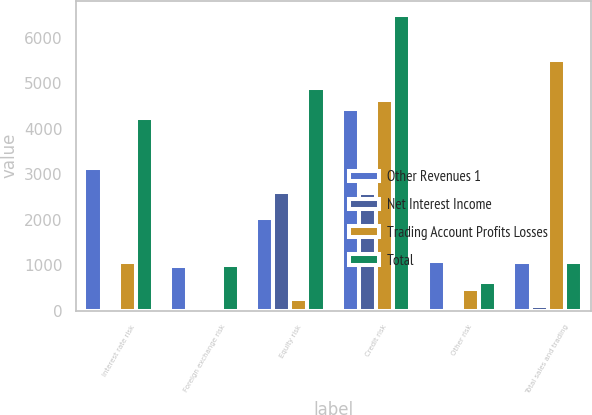Convert chart. <chart><loc_0><loc_0><loc_500><loc_500><stacked_bar_chart><ecel><fcel>Interest rate risk<fcel>Foreign exchange risk<fcel>Equity risk<fcel>Credit risk<fcel>Other risk<fcel>Total sales and trading<nl><fcel>Other Revenues 1<fcel>3145<fcel>972<fcel>2041<fcel>4433<fcel>1084<fcel>1076<nl><fcel>Net Interest Income<fcel>33<fcel>6<fcel>2613<fcel>2576<fcel>13<fcel>89<nl><fcel>Trading Account Profits Losses<fcel>1068<fcel>26<fcel>246<fcel>4637<fcel>469<fcel>5508<nl><fcel>Total<fcel>4246<fcel>1004<fcel>4900<fcel>6494<fcel>628<fcel>1076<nl></chart> 